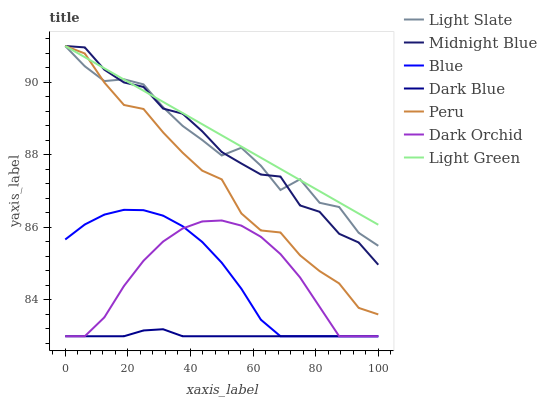Does Dark Blue have the minimum area under the curve?
Answer yes or no. Yes. Does Light Green have the maximum area under the curve?
Answer yes or no. Yes. Does Midnight Blue have the minimum area under the curve?
Answer yes or no. No. Does Midnight Blue have the maximum area under the curve?
Answer yes or no. No. Is Light Green the smoothest?
Answer yes or no. Yes. Is Light Slate the roughest?
Answer yes or no. Yes. Is Midnight Blue the smoothest?
Answer yes or no. No. Is Midnight Blue the roughest?
Answer yes or no. No. Does Blue have the lowest value?
Answer yes or no. Yes. Does Midnight Blue have the lowest value?
Answer yes or no. No. Does Light Green have the highest value?
Answer yes or no. Yes. Does Dark Orchid have the highest value?
Answer yes or no. No. Is Blue less than Light Green?
Answer yes or no. Yes. Is Peru greater than Dark Blue?
Answer yes or no. Yes. Does Dark Orchid intersect Dark Blue?
Answer yes or no. Yes. Is Dark Orchid less than Dark Blue?
Answer yes or no. No. Is Dark Orchid greater than Dark Blue?
Answer yes or no. No. Does Blue intersect Light Green?
Answer yes or no. No. 